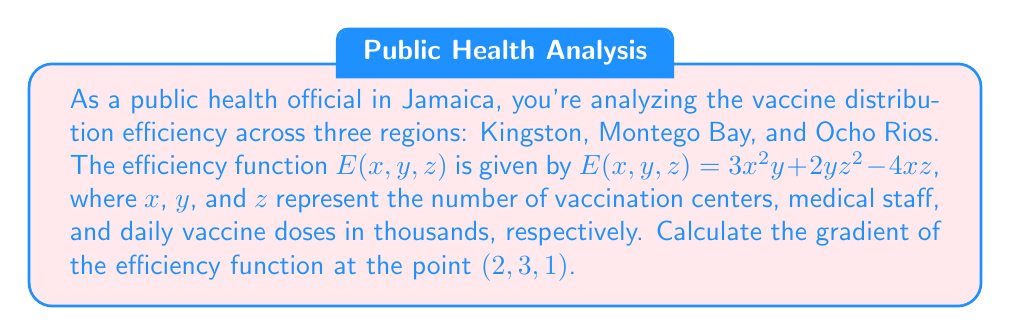Give your solution to this math problem. To find the gradient of the vaccine distribution efficiency function, we need to calculate the partial derivatives with respect to each variable and evaluate them at the given point.

1. Calculate $\frac{\partial E}{\partial x}$:
   $$\frac{\partial E}{\partial x} = 6xy - 4z$$

2. Calculate $\frac{\partial E}{\partial y}$:
   $$\frac{\partial E}{\partial y} = 3x^2 + 2z^2$$

3. Calculate $\frac{\partial E}{\partial z}$:
   $$\frac{\partial E}{\partial z} = 4yz - 4x$$

4. The gradient is given by:
   $$\nabla E = \left(\frac{\partial E}{\partial x}, \frac{\partial E}{\partial y}, \frac{\partial E}{\partial z}\right)$$

5. Evaluate the gradient at the point $(2, 3, 1)$:
   $$\frac{\partial E}{\partial x}|_{(2,3,1)} = 6(2)(3) - 4(1) = 32$$
   $$\frac{\partial E}{\partial y}|_{(2,3,1)} = 3(2)^2 + 2(1)^2 = 14$$
   $$\frac{\partial E}{\partial z}|_{(2,3,1)} = 4(3)(1) - 4(2) = 4$$

6. Combine the results:
   $$\nabla E|_{(2,3,1)} = (32, 14, 4)$$
Answer: $(32, 14, 4)$ 